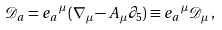<formula> <loc_0><loc_0><loc_500><loc_500>\mathcal { D } _ { a } = e _ { a } \, ^ { \mu } ( \nabla _ { \mu } - A _ { \mu } \partial _ { 5 } ) \equiv e _ { a } \, ^ { \mu } \mathcal { D } _ { \mu } \, ,</formula> 